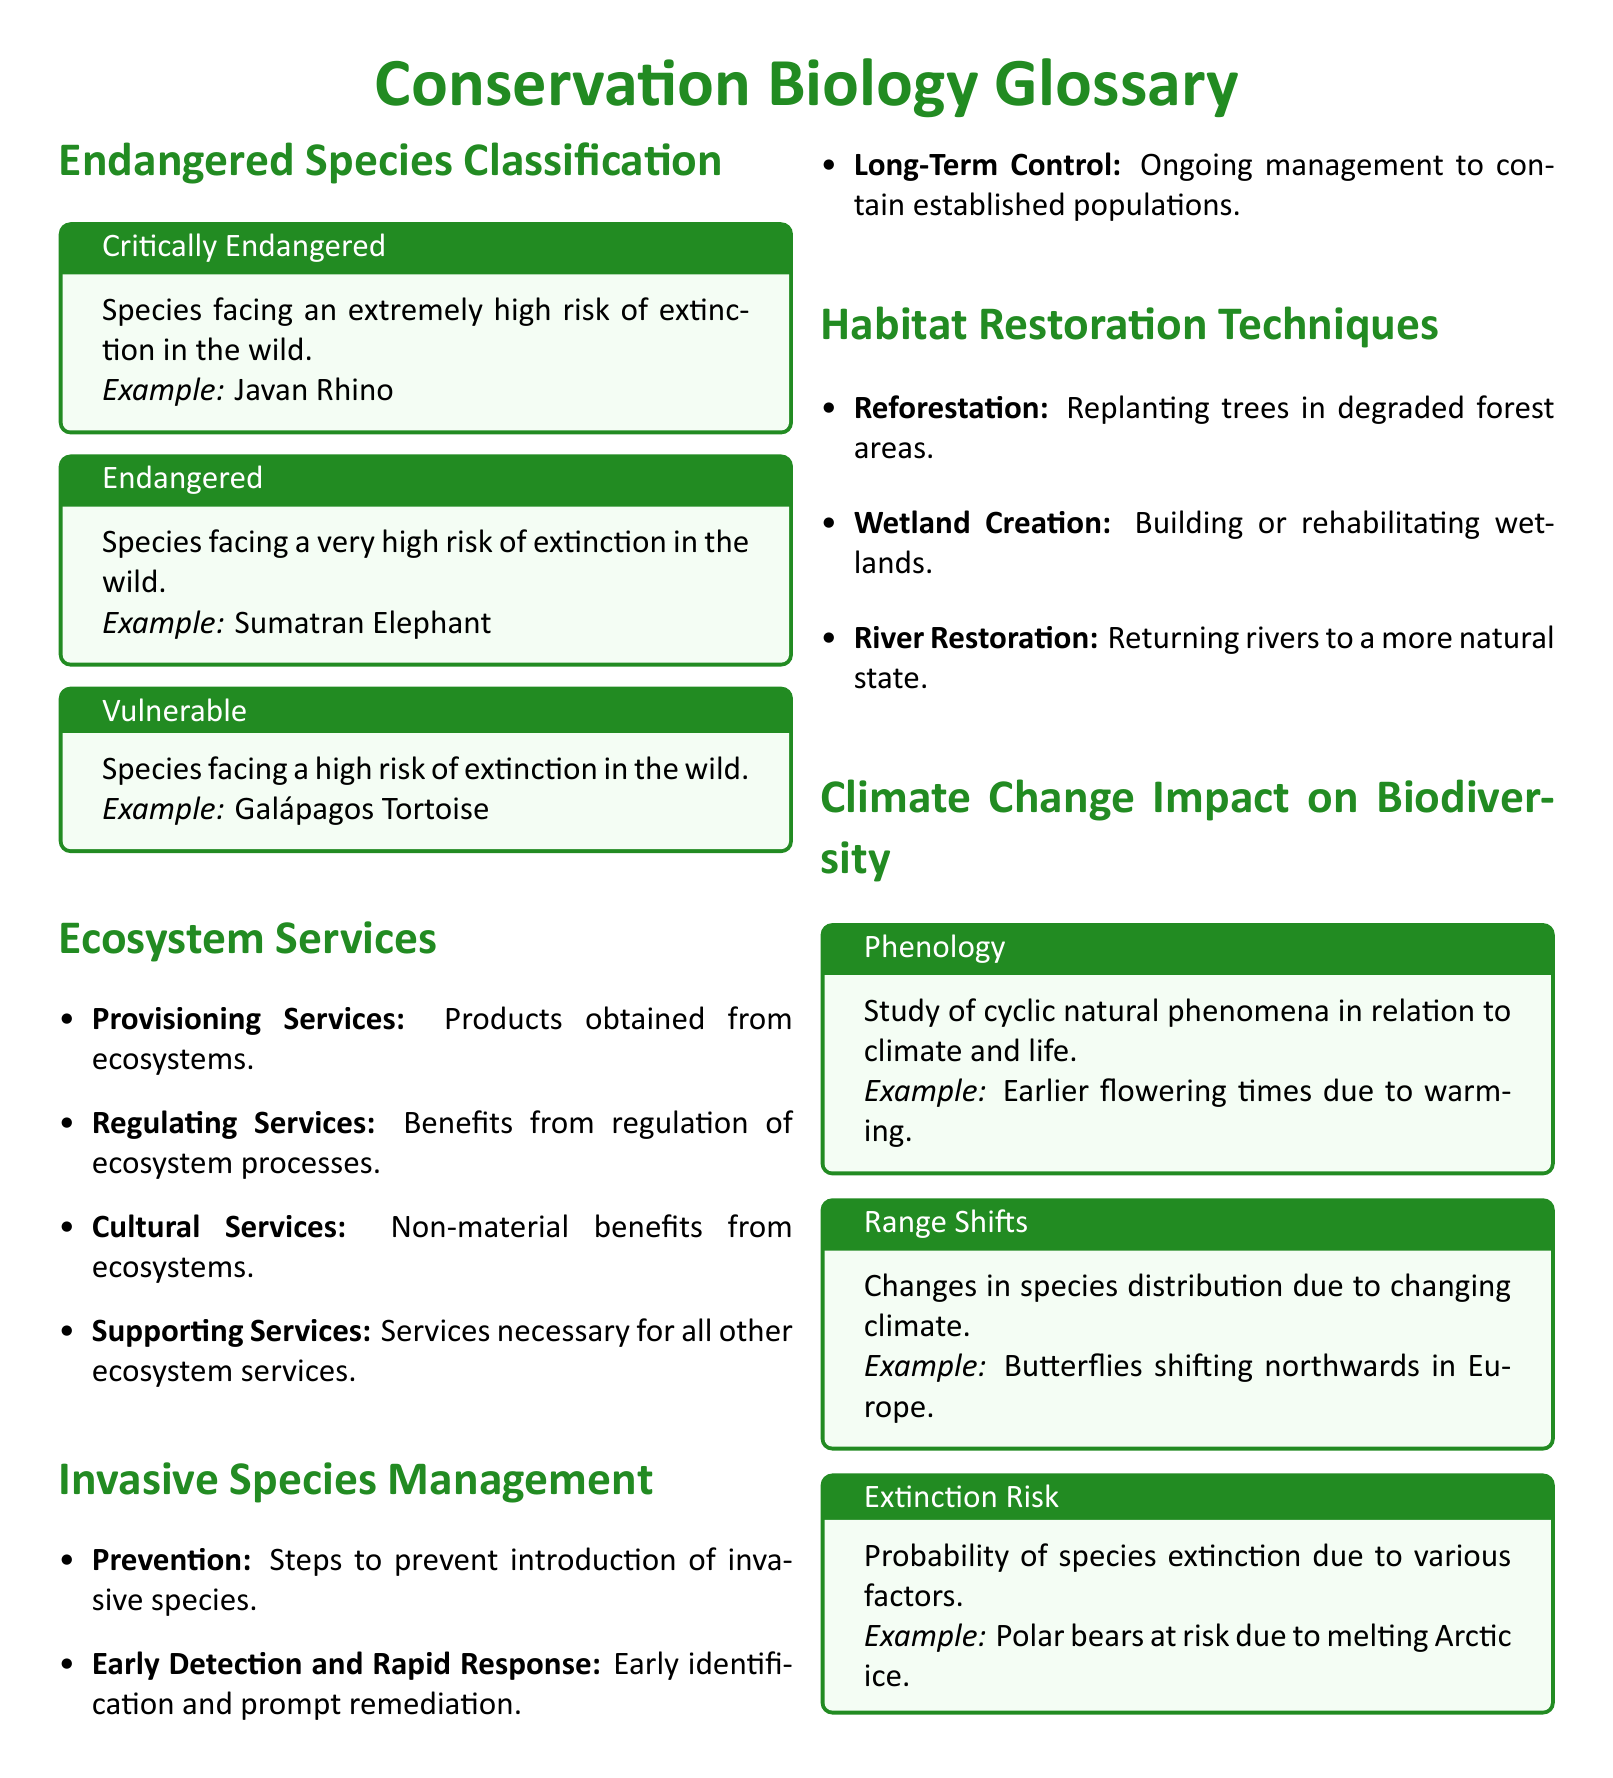What species is classified as "Critically Endangered"? The document provides an example of a species facing an extremely high risk of extinction in the wild, which is the Javan Rhino.
Answer: Javan Rhino What does "Vulnerable" indicate in the Endangered Species Classification? The document states it refers to species facing a high risk of extinction in the wild.
Answer: High risk of extinction What are the four categories of ecosystem services listed? The document enumerates Provisioning, Regulating, Cultural, and Supporting services.
Answer: Provisioning, Regulating, Cultural, Supporting What is the first strategy mentioned under Invasive Species Management? The document specifies that Prevention is the first strategy to prevent introduction of invasive species.
Answer: Prevention What does "Phenology" study? The document explains it as the study of cyclic natural phenomena in relation to climate and life.
Answer: Cyclic natural phenomena How are butterflies in Europe affected by climate change according to the document? It states that butterflies are shifting northwards due to changing climate conditions.
Answer: Shifting northwards What is the purpose of reforestation in habitat restoration techniques? The document describes reforestation as replanting trees in degraded forest areas.
Answer: Replanting trees What example is given for a species at risk due to climate change? The document mentions polar bears as an example of a species at risk due to melting Arctic ice.
Answer: Polar bears 